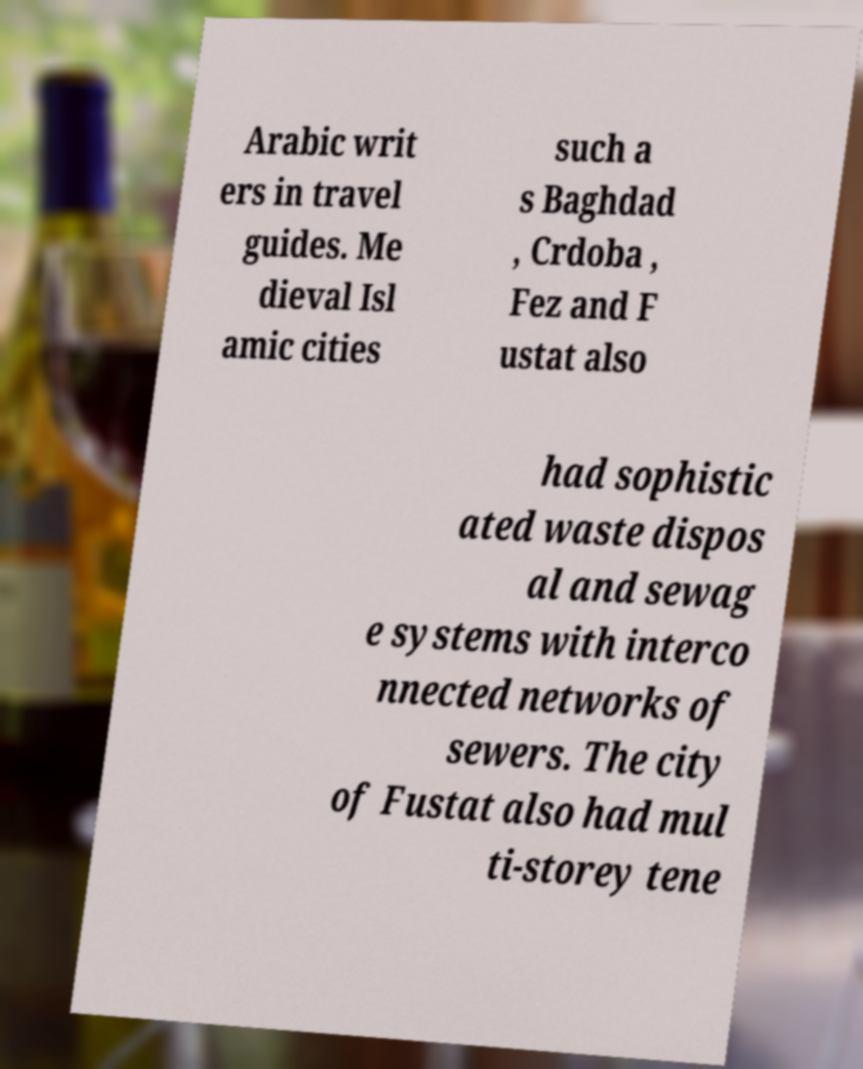What messages or text are displayed in this image? I need them in a readable, typed format. Arabic writ ers in travel guides. Me dieval Isl amic cities such a s Baghdad , Crdoba , Fez and F ustat also had sophistic ated waste dispos al and sewag e systems with interco nnected networks of sewers. The city of Fustat also had mul ti-storey tene 